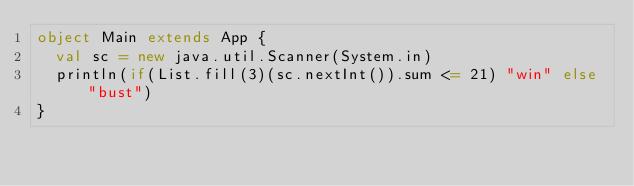Convert code to text. <code><loc_0><loc_0><loc_500><loc_500><_Scala_>object Main extends App {
  val sc = new java.util.Scanner(System.in)
  println(if(List.fill(3)(sc.nextInt()).sum <= 21) "win" else "bust")
}
</code> 